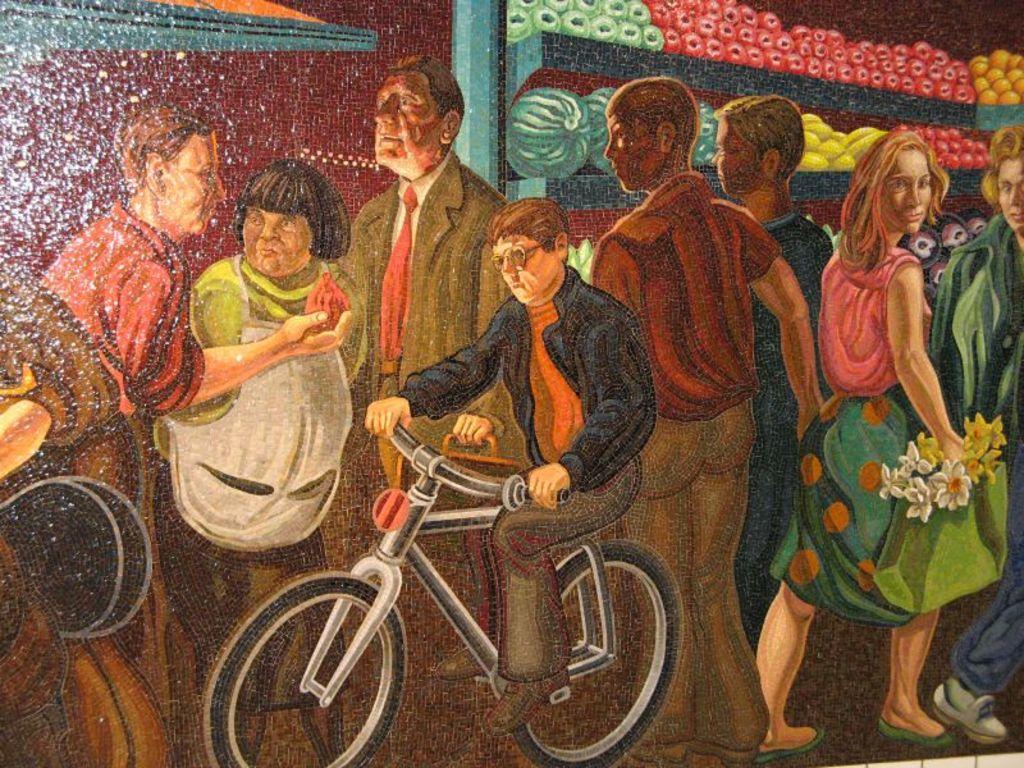Could you give a brief overview of what you see in this image? In this image, there is an art contains some persons standing and wearing clothes. There is a person in the middle of the image riding a bicycle. There are some fruits in the top right of the image. 